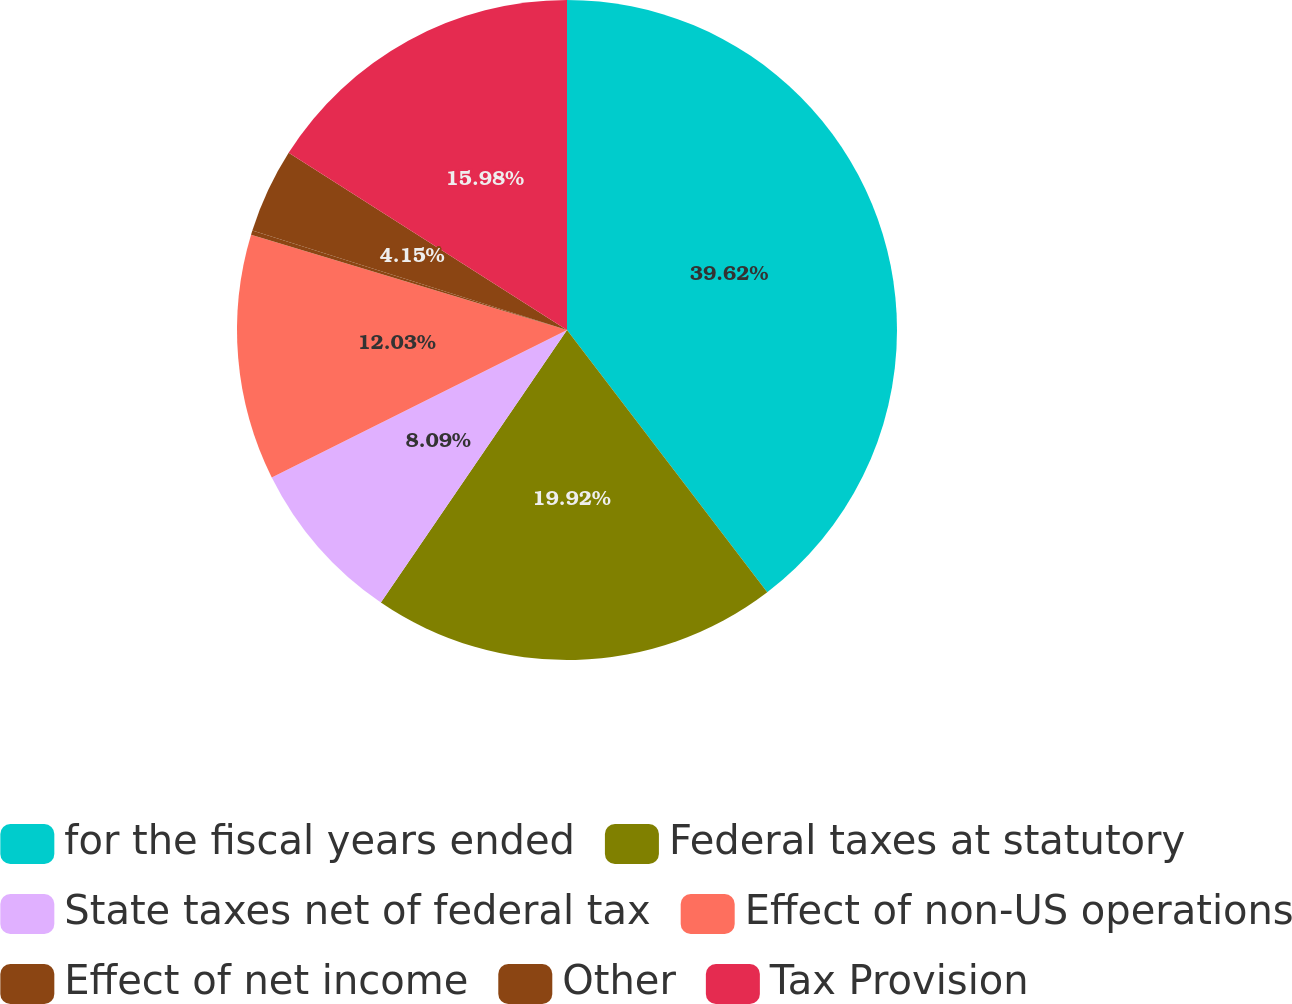<chart> <loc_0><loc_0><loc_500><loc_500><pie_chart><fcel>for the fiscal years ended<fcel>Federal taxes at statutory<fcel>State taxes net of federal tax<fcel>Effect of non-US operations<fcel>Effect of net income<fcel>Other<fcel>Tax Provision<nl><fcel>39.61%<fcel>19.91%<fcel>8.09%<fcel>12.03%<fcel>0.21%<fcel>4.15%<fcel>15.97%<nl></chart> 